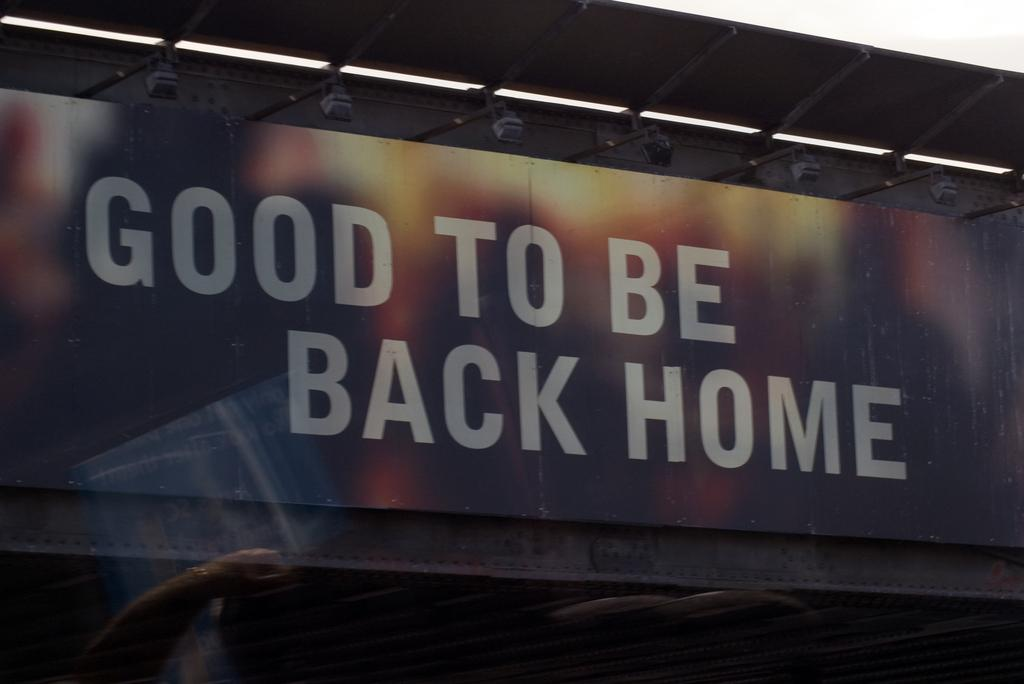Provide a one-sentence caption for the provided image. An outdoor sign which reads "Good to be back home.". 